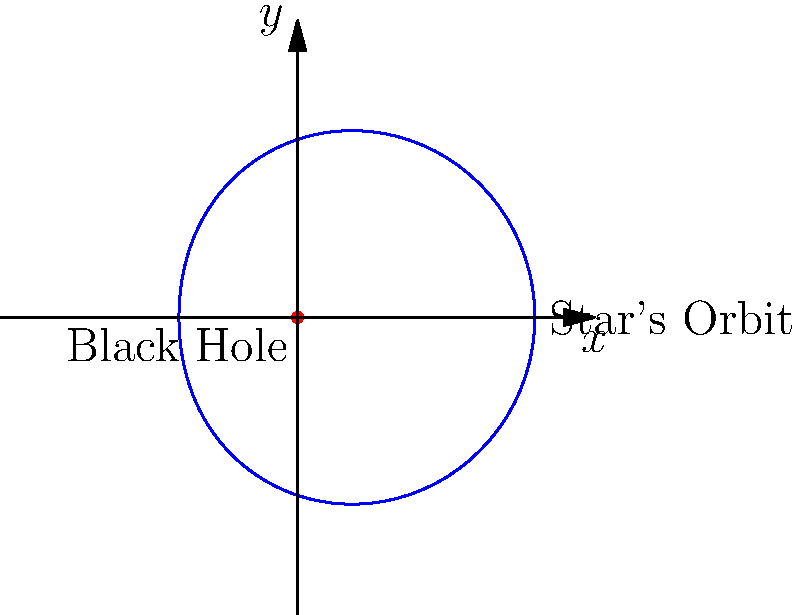As an innovative inventor pushing the boundaries of science, you're developing a new method to estimate black hole masses. Given a star orbiting a black hole with a velocity of $2.5 \times 10^4$ m/s at a distance of $3 \times 10^{13}$ m, estimate the mass of the black hole using the equation $M = \frac{v^2r}{G}$, where $G = 6.67 \times 10^{-11}$ $\text{m}^3 \text{kg}^{-1} \text{s}^{-2}$. How might this method revolutionize our understanding of distant black holes? To estimate the mass of the black hole, we'll use the given equation and the provided data:

1. Given:
   - Orbital velocity ($v$) = $2.5 \times 10^4$ m/s
   - Orbital radius ($r$) = $3 \times 10^{13}$ m
   - Gravitational constant ($G$) = $6.67 \times 10^{-11}$ $\text{m}^3 \text{kg}^{-1} \text{s}^{-2}$

2. Equation: $M = \frac{v^2r}{G}$

3. Substituting the values:
   $M = \frac{(2.5 \times 10^4)^2 \times (3 \times 10^{13})}{6.67 \times 10^{-11}}$

4. Calculate:
   $M = \frac{(6.25 \times 10^8) \times (3 \times 10^{13})}{6.67 \times 10^{-11}}$
   $M = \frac{1.875 \times 10^{22}}{6.67 \times 10^{-11}}$
   $M = 2.81 \times 10^{32}$ kg

5. Convert to solar masses (1 solar mass ≈ $1.989 \times 10^{30}$ kg):
   $M_{solar} = \frac{2.81 \times 10^{32}}{1.989 \times 10^{30}} \approx 141$ solar masses

This method could revolutionize our understanding of distant black holes by:
1. Providing a relatively simple way to estimate black hole masses using observable star orbits.
2. Allowing for mass estimations of black holes that are too far for direct observation.
3. Enabling the study of black hole populations and their evolution over cosmic time.
4. Facilitating the investigation of the relationship between black hole mass and galaxy properties.
Answer: 141 solar masses 